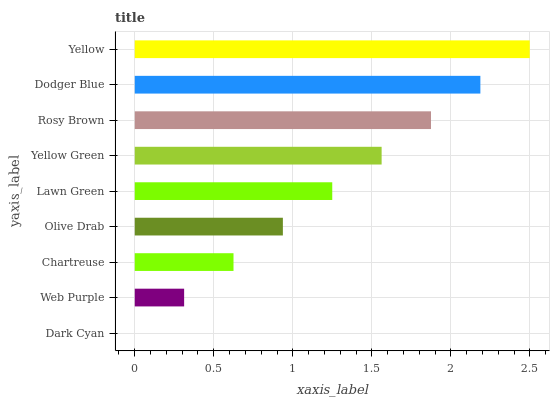Is Dark Cyan the minimum?
Answer yes or no. Yes. Is Yellow the maximum?
Answer yes or no. Yes. Is Web Purple the minimum?
Answer yes or no. No. Is Web Purple the maximum?
Answer yes or no. No. Is Web Purple greater than Dark Cyan?
Answer yes or no. Yes. Is Dark Cyan less than Web Purple?
Answer yes or no. Yes. Is Dark Cyan greater than Web Purple?
Answer yes or no. No. Is Web Purple less than Dark Cyan?
Answer yes or no. No. Is Lawn Green the high median?
Answer yes or no. Yes. Is Lawn Green the low median?
Answer yes or no. Yes. Is Rosy Brown the high median?
Answer yes or no. No. Is Dodger Blue the low median?
Answer yes or no. No. 